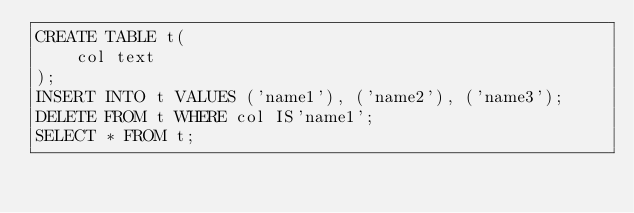<code> <loc_0><loc_0><loc_500><loc_500><_SQL_>CREATE TABLE t(
    col text
);
INSERT INTO t VALUES ('name1'), ('name2'), ('name3');
DELETE FROM t WHERE col IS'name1';
SELECT * FROM t;
</code> 